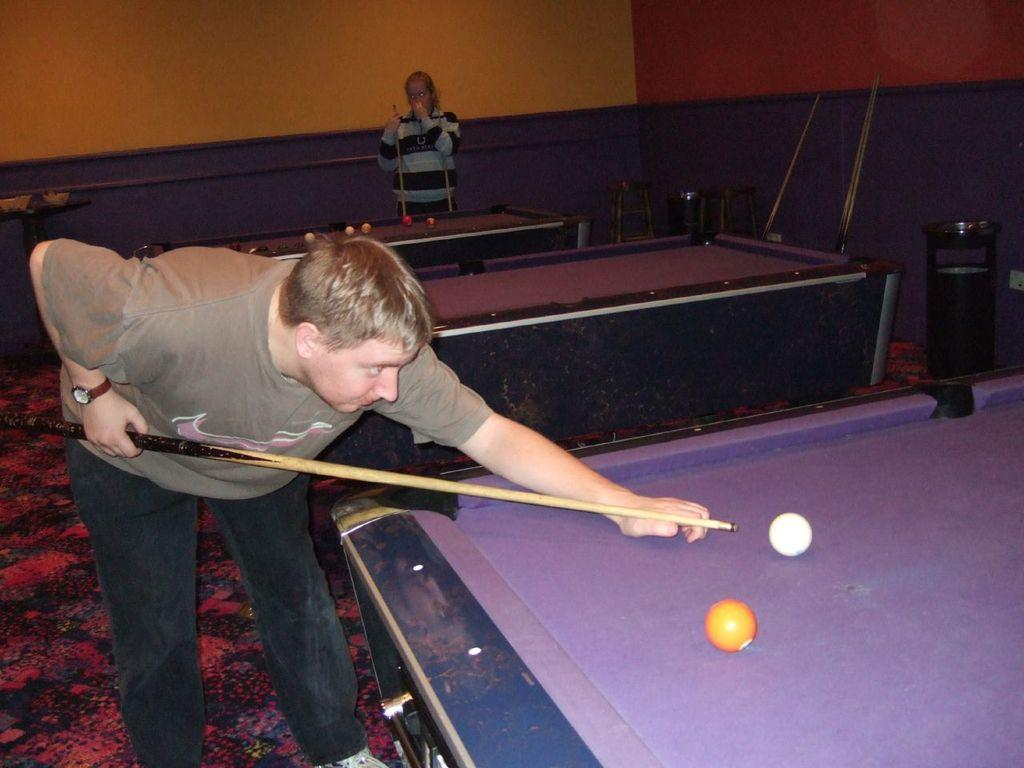What is the main subject of the image? There is a man in the image. What is the man holding in the image? The man is holding a snooker stick. How is the man holding the snooker stick? The man is holding the snooker stick with both hands. What type of lipstick is the man applying in the image? There is no lipstick or any indication of the man applying lipstick in the image. 